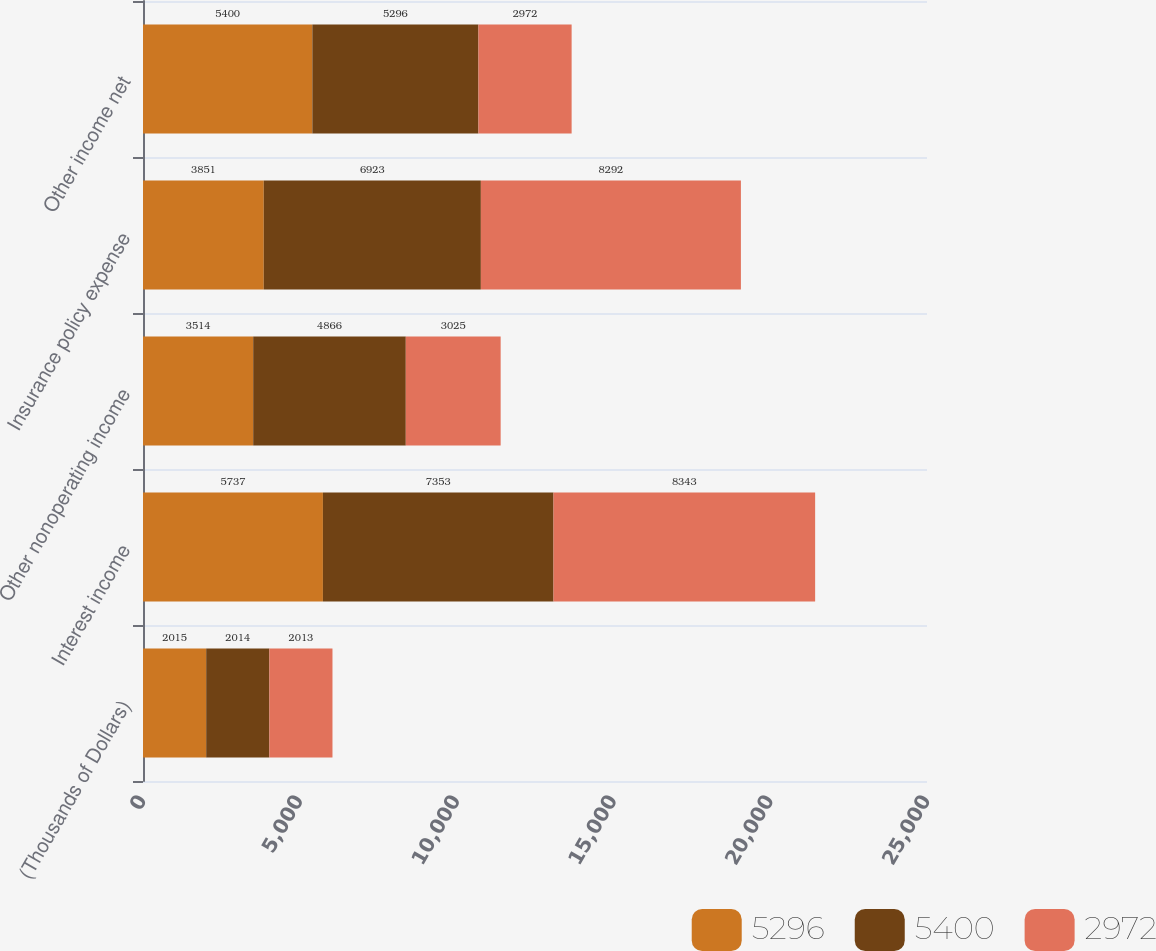<chart> <loc_0><loc_0><loc_500><loc_500><stacked_bar_chart><ecel><fcel>(Thousands of Dollars)<fcel>Interest income<fcel>Other nonoperating income<fcel>Insurance policy expense<fcel>Other income net<nl><fcel>5296<fcel>2015<fcel>5737<fcel>3514<fcel>3851<fcel>5400<nl><fcel>5400<fcel>2014<fcel>7353<fcel>4866<fcel>6923<fcel>5296<nl><fcel>2972<fcel>2013<fcel>8343<fcel>3025<fcel>8292<fcel>2972<nl></chart> 